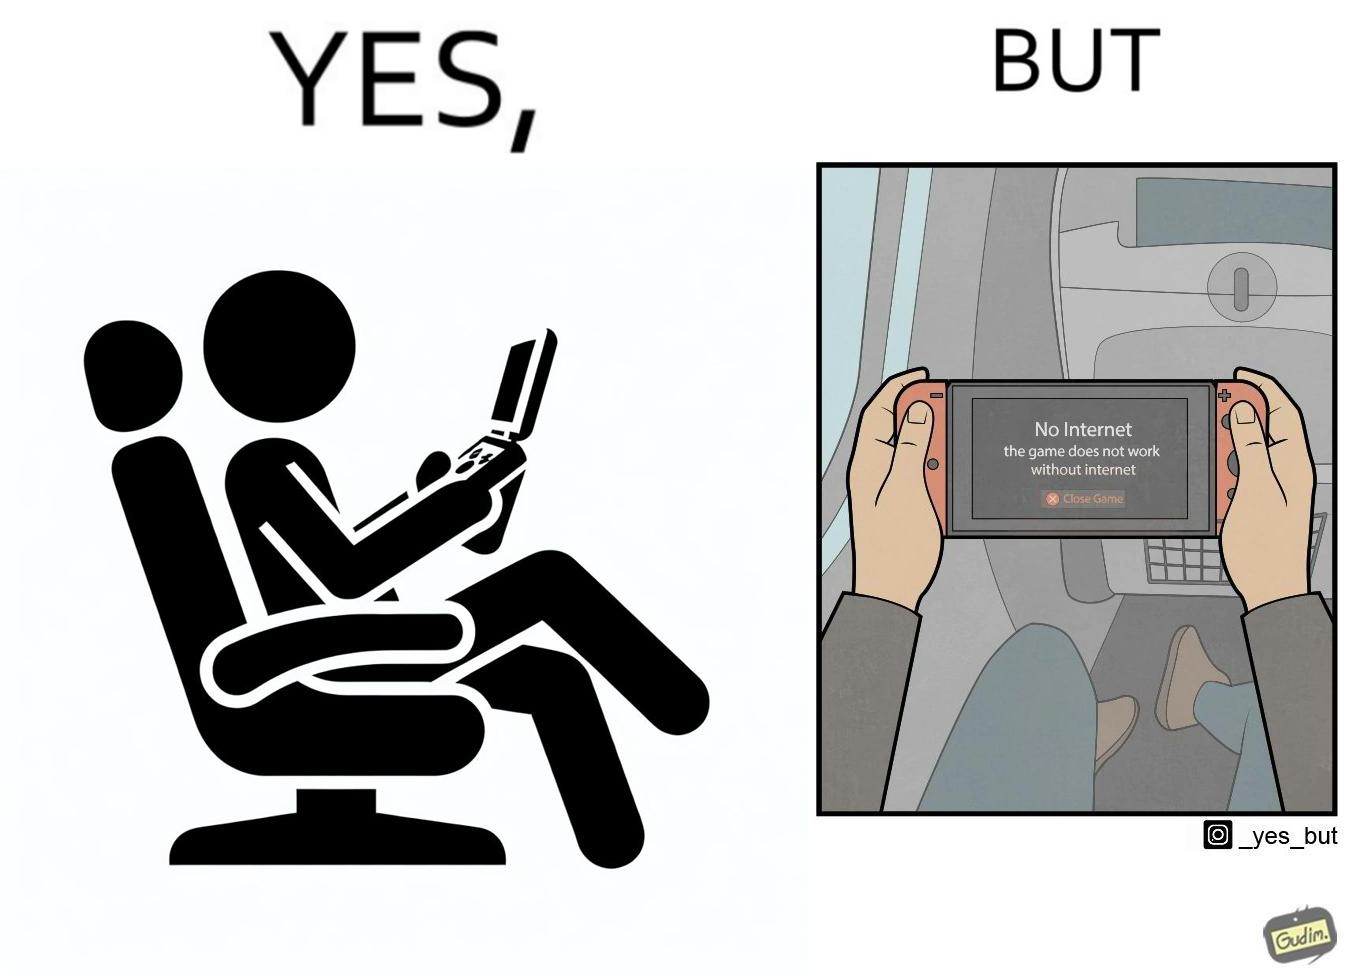Provide a description of this image. The image is ironic, as the person is holding the game console to play a game during the flight. However, the person is unable to play the game, as the game requires internet (as is the case with many modern games), and internet is unavailable in many lights. 